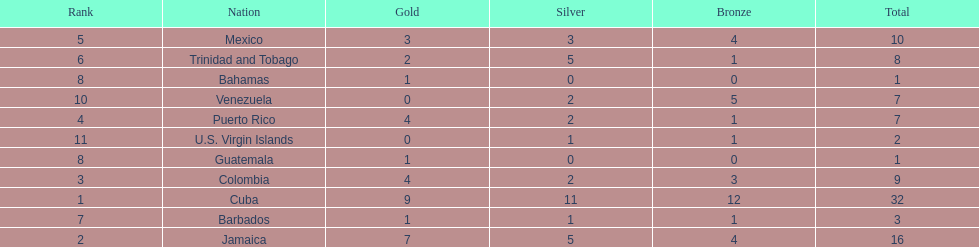The nation before mexico in the table Puerto Rico. 